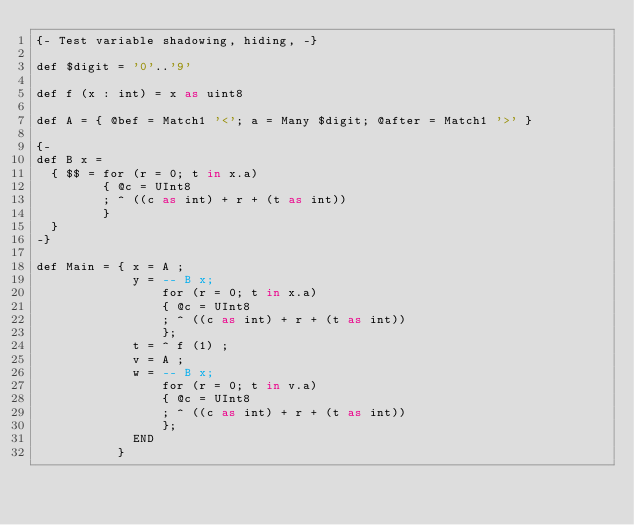Convert code to text. <code><loc_0><loc_0><loc_500><loc_500><_SQL_>{- Test variable shadowing, hiding, -}

def $digit = '0'..'9'

def f (x : int) = x as uint8

def A = { @bef = Match1 '<'; a = Many $digit; @after = Match1 '>' }

{-
def B x =
  { $$ = for (r = 0; t in x.a)
         { @c = UInt8
         ; ^ ((c as int) + r + (t as int))
         }
  }
-}

def Main = { x = A ;
             y = -- B x;
                 for (r = 0; t in x.a)
                 { @c = UInt8
                 ; ^ ((c as int) + r + (t as int))
                 };
             t = ^ f (1) ;
             v = A ;
             w = -- B x;
                 for (r = 0; t in v.a)
                 { @c = UInt8
                 ; ^ ((c as int) + r + (t as int))
                 };
             END
           }
</code> 